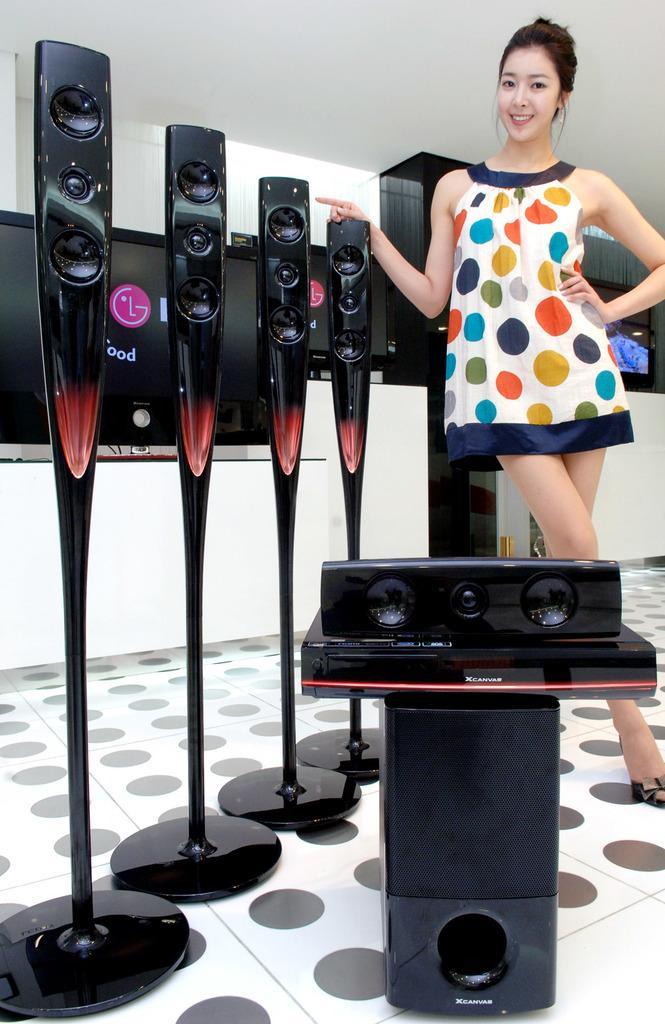In one or two sentences, can you explain what this image depicts? In this picture there is a woman standing and smiling. In the foreground there is a speaker and there are objects. At the back there are monitors and there is text on the screen. At the bottom there is a floor. 